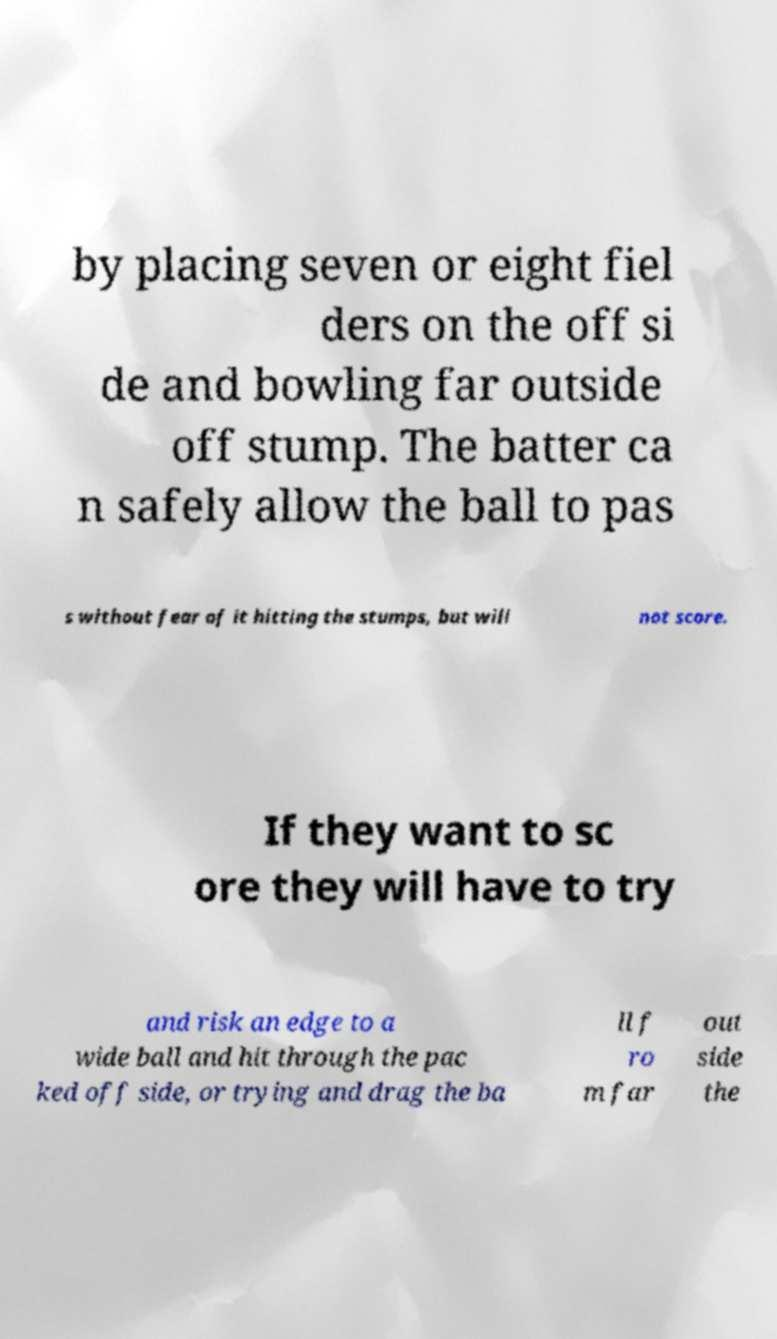Could you assist in decoding the text presented in this image and type it out clearly? by placing seven or eight fiel ders on the off si de and bowling far outside off stump. The batter ca n safely allow the ball to pas s without fear of it hitting the stumps, but will not score. If they want to sc ore they will have to try and risk an edge to a wide ball and hit through the pac ked off side, or trying and drag the ba ll f ro m far out side the 